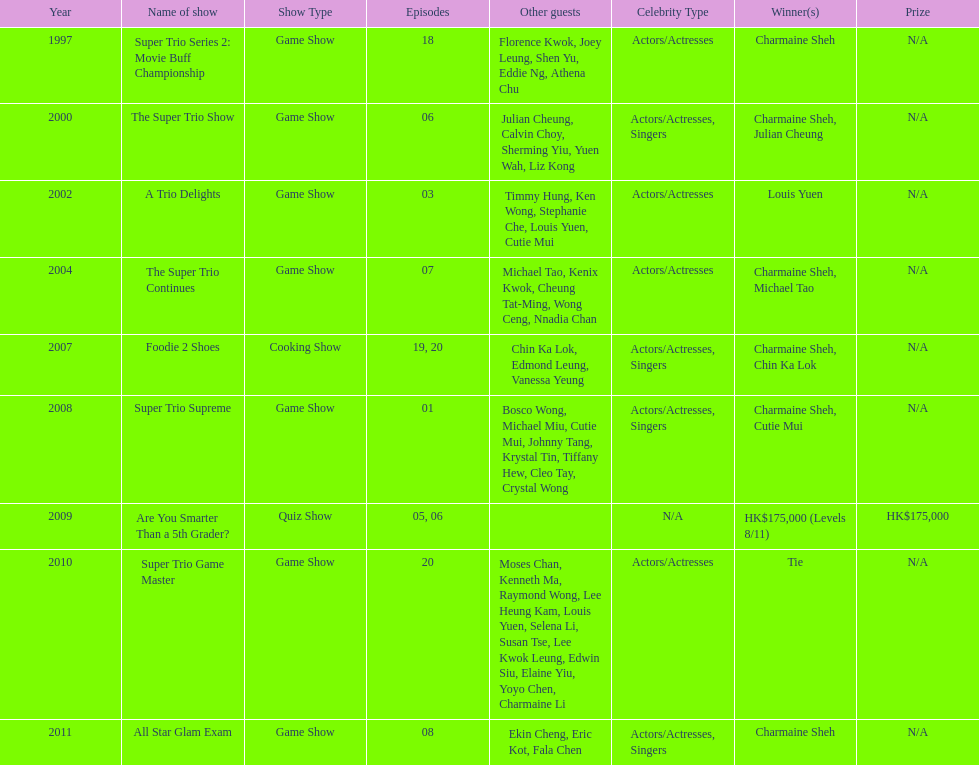How many consecutive trio shows did charmaine sheh do before being on another variety program? 34. 